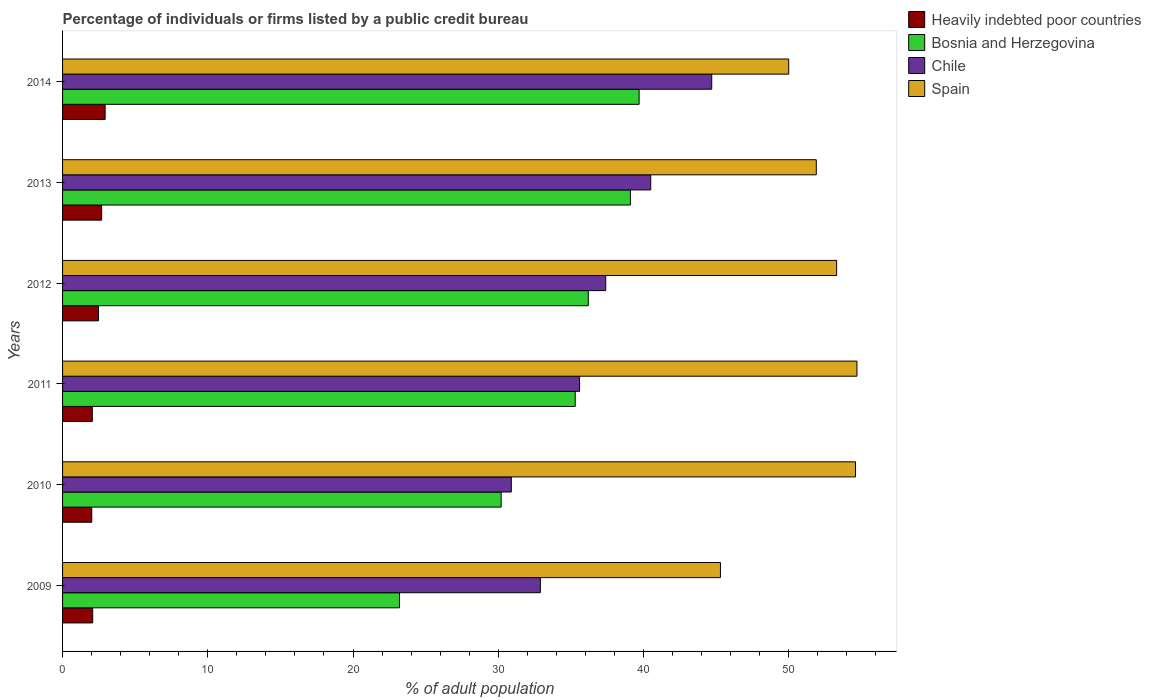How many different coloured bars are there?
Make the answer very short. 4. How many groups of bars are there?
Make the answer very short. 6. Are the number of bars per tick equal to the number of legend labels?
Ensure brevity in your answer.  Yes. How many bars are there on the 3rd tick from the bottom?
Offer a very short reply. 4. In how many cases, is the number of bars for a given year not equal to the number of legend labels?
Your answer should be very brief. 0. What is the percentage of population listed by a public credit bureau in Spain in 2011?
Your answer should be compact. 54.7. Across all years, what is the maximum percentage of population listed by a public credit bureau in Bosnia and Herzegovina?
Provide a short and direct response. 39.7. Across all years, what is the minimum percentage of population listed by a public credit bureau in Heavily indebted poor countries?
Your response must be concise. 2.01. In which year was the percentage of population listed by a public credit bureau in Heavily indebted poor countries minimum?
Offer a very short reply. 2010. What is the total percentage of population listed by a public credit bureau in Chile in the graph?
Offer a terse response. 222. What is the difference between the percentage of population listed by a public credit bureau in Heavily indebted poor countries in 2013 and that in 2014?
Offer a terse response. -0.24. What is the difference between the percentage of population listed by a public credit bureau in Spain in 2009 and the percentage of population listed by a public credit bureau in Chile in 2011?
Your answer should be compact. 9.7. In the year 2013, what is the difference between the percentage of population listed by a public credit bureau in Chile and percentage of population listed by a public credit bureau in Heavily indebted poor countries?
Offer a terse response. 37.81. In how many years, is the percentage of population listed by a public credit bureau in Bosnia and Herzegovina greater than 26 %?
Your response must be concise. 5. What is the ratio of the percentage of population listed by a public credit bureau in Bosnia and Herzegovina in 2011 to that in 2014?
Make the answer very short. 0.89. Is the difference between the percentage of population listed by a public credit bureau in Chile in 2010 and 2014 greater than the difference between the percentage of population listed by a public credit bureau in Heavily indebted poor countries in 2010 and 2014?
Give a very brief answer. No. What is the difference between the highest and the second highest percentage of population listed by a public credit bureau in Spain?
Give a very brief answer. 0.1. What is the difference between the highest and the lowest percentage of population listed by a public credit bureau in Heavily indebted poor countries?
Offer a very short reply. 0.92. What does the 1st bar from the bottom in 2013 represents?
Provide a succinct answer. Heavily indebted poor countries. How many bars are there?
Offer a very short reply. 24. How many years are there in the graph?
Ensure brevity in your answer.  6. What is the difference between two consecutive major ticks on the X-axis?
Offer a terse response. 10. Where does the legend appear in the graph?
Ensure brevity in your answer.  Top right. How are the legend labels stacked?
Give a very brief answer. Vertical. What is the title of the graph?
Offer a terse response. Percentage of individuals or firms listed by a public credit bureau. Does "Guam" appear as one of the legend labels in the graph?
Provide a short and direct response. No. What is the label or title of the X-axis?
Make the answer very short. % of adult population. What is the label or title of the Y-axis?
Make the answer very short. Years. What is the % of adult population of Heavily indebted poor countries in 2009?
Offer a terse response. 2.07. What is the % of adult population in Bosnia and Herzegovina in 2009?
Provide a short and direct response. 23.2. What is the % of adult population of Chile in 2009?
Give a very brief answer. 32.9. What is the % of adult population in Spain in 2009?
Provide a succinct answer. 45.3. What is the % of adult population of Heavily indebted poor countries in 2010?
Give a very brief answer. 2.01. What is the % of adult population of Bosnia and Herzegovina in 2010?
Provide a short and direct response. 30.2. What is the % of adult population in Chile in 2010?
Your response must be concise. 30.9. What is the % of adult population in Spain in 2010?
Provide a succinct answer. 54.6. What is the % of adult population in Heavily indebted poor countries in 2011?
Offer a terse response. 2.05. What is the % of adult population in Bosnia and Herzegovina in 2011?
Your answer should be compact. 35.3. What is the % of adult population in Chile in 2011?
Give a very brief answer. 35.6. What is the % of adult population of Spain in 2011?
Give a very brief answer. 54.7. What is the % of adult population of Heavily indebted poor countries in 2012?
Your answer should be very brief. 2.48. What is the % of adult population of Bosnia and Herzegovina in 2012?
Keep it short and to the point. 36.2. What is the % of adult population of Chile in 2012?
Make the answer very short. 37.4. What is the % of adult population of Spain in 2012?
Provide a succinct answer. 53.3. What is the % of adult population of Heavily indebted poor countries in 2013?
Offer a very short reply. 2.69. What is the % of adult population of Bosnia and Herzegovina in 2013?
Provide a short and direct response. 39.1. What is the % of adult population in Chile in 2013?
Give a very brief answer. 40.5. What is the % of adult population of Spain in 2013?
Your response must be concise. 51.9. What is the % of adult population of Heavily indebted poor countries in 2014?
Give a very brief answer. 2.93. What is the % of adult population in Bosnia and Herzegovina in 2014?
Provide a succinct answer. 39.7. What is the % of adult population in Chile in 2014?
Your answer should be compact. 44.7. Across all years, what is the maximum % of adult population of Heavily indebted poor countries?
Your response must be concise. 2.93. Across all years, what is the maximum % of adult population of Bosnia and Herzegovina?
Offer a terse response. 39.7. Across all years, what is the maximum % of adult population in Chile?
Your answer should be very brief. 44.7. Across all years, what is the maximum % of adult population of Spain?
Offer a terse response. 54.7. Across all years, what is the minimum % of adult population of Heavily indebted poor countries?
Keep it short and to the point. 2.01. Across all years, what is the minimum % of adult population in Bosnia and Herzegovina?
Give a very brief answer. 23.2. Across all years, what is the minimum % of adult population in Chile?
Offer a terse response. 30.9. Across all years, what is the minimum % of adult population of Spain?
Offer a very short reply. 45.3. What is the total % of adult population of Heavily indebted poor countries in the graph?
Make the answer very short. 14.23. What is the total % of adult population in Bosnia and Herzegovina in the graph?
Provide a succinct answer. 203.7. What is the total % of adult population of Chile in the graph?
Your response must be concise. 222. What is the total % of adult population in Spain in the graph?
Make the answer very short. 309.8. What is the difference between the % of adult population in Heavily indebted poor countries in 2009 and that in 2010?
Your answer should be compact. 0.06. What is the difference between the % of adult population of Bosnia and Herzegovina in 2009 and that in 2010?
Provide a succinct answer. -7. What is the difference between the % of adult population of Spain in 2009 and that in 2010?
Your answer should be compact. -9.3. What is the difference between the % of adult population in Heavily indebted poor countries in 2009 and that in 2011?
Offer a very short reply. 0.03. What is the difference between the % of adult population in Bosnia and Herzegovina in 2009 and that in 2011?
Offer a very short reply. -12.1. What is the difference between the % of adult population of Chile in 2009 and that in 2011?
Offer a terse response. -2.7. What is the difference between the % of adult population in Heavily indebted poor countries in 2009 and that in 2012?
Offer a very short reply. -0.4. What is the difference between the % of adult population in Chile in 2009 and that in 2012?
Ensure brevity in your answer.  -4.5. What is the difference between the % of adult population of Heavily indebted poor countries in 2009 and that in 2013?
Your answer should be compact. -0.62. What is the difference between the % of adult population of Bosnia and Herzegovina in 2009 and that in 2013?
Provide a succinct answer. -15.9. What is the difference between the % of adult population in Chile in 2009 and that in 2013?
Give a very brief answer. -7.6. What is the difference between the % of adult population of Spain in 2009 and that in 2013?
Provide a succinct answer. -6.6. What is the difference between the % of adult population of Heavily indebted poor countries in 2009 and that in 2014?
Offer a terse response. -0.86. What is the difference between the % of adult population of Bosnia and Herzegovina in 2009 and that in 2014?
Your answer should be very brief. -16.5. What is the difference between the % of adult population of Spain in 2009 and that in 2014?
Your answer should be very brief. -4.7. What is the difference between the % of adult population in Heavily indebted poor countries in 2010 and that in 2011?
Your response must be concise. -0.04. What is the difference between the % of adult population in Bosnia and Herzegovina in 2010 and that in 2011?
Make the answer very short. -5.1. What is the difference between the % of adult population in Spain in 2010 and that in 2011?
Your response must be concise. -0.1. What is the difference between the % of adult population of Heavily indebted poor countries in 2010 and that in 2012?
Your response must be concise. -0.47. What is the difference between the % of adult population of Chile in 2010 and that in 2012?
Ensure brevity in your answer.  -6.5. What is the difference between the % of adult population in Heavily indebted poor countries in 2010 and that in 2013?
Ensure brevity in your answer.  -0.68. What is the difference between the % of adult population of Heavily indebted poor countries in 2010 and that in 2014?
Ensure brevity in your answer.  -0.92. What is the difference between the % of adult population of Spain in 2010 and that in 2014?
Provide a succinct answer. 4.6. What is the difference between the % of adult population of Heavily indebted poor countries in 2011 and that in 2012?
Provide a short and direct response. -0.43. What is the difference between the % of adult population in Bosnia and Herzegovina in 2011 and that in 2012?
Your answer should be compact. -0.9. What is the difference between the % of adult population in Chile in 2011 and that in 2012?
Offer a very short reply. -1.8. What is the difference between the % of adult population of Spain in 2011 and that in 2012?
Your response must be concise. 1.4. What is the difference between the % of adult population in Heavily indebted poor countries in 2011 and that in 2013?
Make the answer very short. -0.64. What is the difference between the % of adult population in Bosnia and Herzegovina in 2011 and that in 2013?
Offer a very short reply. -3.8. What is the difference between the % of adult population in Chile in 2011 and that in 2013?
Ensure brevity in your answer.  -4.9. What is the difference between the % of adult population in Spain in 2011 and that in 2013?
Keep it short and to the point. 2.8. What is the difference between the % of adult population of Heavily indebted poor countries in 2011 and that in 2014?
Provide a short and direct response. -0.88. What is the difference between the % of adult population in Bosnia and Herzegovina in 2011 and that in 2014?
Provide a short and direct response. -4.4. What is the difference between the % of adult population in Heavily indebted poor countries in 2012 and that in 2013?
Provide a short and direct response. -0.22. What is the difference between the % of adult population in Bosnia and Herzegovina in 2012 and that in 2013?
Offer a terse response. -2.9. What is the difference between the % of adult population of Chile in 2012 and that in 2013?
Give a very brief answer. -3.1. What is the difference between the % of adult population of Spain in 2012 and that in 2013?
Your answer should be compact. 1.4. What is the difference between the % of adult population in Heavily indebted poor countries in 2012 and that in 2014?
Offer a very short reply. -0.46. What is the difference between the % of adult population of Chile in 2012 and that in 2014?
Keep it short and to the point. -7.3. What is the difference between the % of adult population of Heavily indebted poor countries in 2013 and that in 2014?
Give a very brief answer. -0.24. What is the difference between the % of adult population of Spain in 2013 and that in 2014?
Offer a very short reply. 1.9. What is the difference between the % of adult population in Heavily indebted poor countries in 2009 and the % of adult population in Bosnia and Herzegovina in 2010?
Provide a succinct answer. -28.13. What is the difference between the % of adult population of Heavily indebted poor countries in 2009 and the % of adult population of Chile in 2010?
Your answer should be very brief. -28.83. What is the difference between the % of adult population of Heavily indebted poor countries in 2009 and the % of adult population of Spain in 2010?
Ensure brevity in your answer.  -52.53. What is the difference between the % of adult population in Bosnia and Herzegovina in 2009 and the % of adult population in Chile in 2010?
Your response must be concise. -7.7. What is the difference between the % of adult population in Bosnia and Herzegovina in 2009 and the % of adult population in Spain in 2010?
Provide a succinct answer. -31.4. What is the difference between the % of adult population of Chile in 2009 and the % of adult population of Spain in 2010?
Make the answer very short. -21.7. What is the difference between the % of adult population in Heavily indebted poor countries in 2009 and the % of adult population in Bosnia and Herzegovina in 2011?
Give a very brief answer. -33.23. What is the difference between the % of adult population in Heavily indebted poor countries in 2009 and the % of adult population in Chile in 2011?
Keep it short and to the point. -33.53. What is the difference between the % of adult population in Heavily indebted poor countries in 2009 and the % of adult population in Spain in 2011?
Ensure brevity in your answer.  -52.63. What is the difference between the % of adult population of Bosnia and Herzegovina in 2009 and the % of adult population of Chile in 2011?
Offer a terse response. -12.4. What is the difference between the % of adult population in Bosnia and Herzegovina in 2009 and the % of adult population in Spain in 2011?
Your response must be concise. -31.5. What is the difference between the % of adult population in Chile in 2009 and the % of adult population in Spain in 2011?
Your answer should be compact. -21.8. What is the difference between the % of adult population of Heavily indebted poor countries in 2009 and the % of adult population of Bosnia and Herzegovina in 2012?
Offer a very short reply. -34.13. What is the difference between the % of adult population of Heavily indebted poor countries in 2009 and the % of adult population of Chile in 2012?
Offer a terse response. -35.33. What is the difference between the % of adult population in Heavily indebted poor countries in 2009 and the % of adult population in Spain in 2012?
Your answer should be very brief. -51.23. What is the difference between the % of adult population of Bosnia and Herzegovina in 2009 and the % of adult population of Chile in 2012?
Provide a short and direct response. -14.2. What is the difference between the % of adult population in Bosnia and Herzegovina in 2009 and the % of adult population in Spain in 2012?
Keep it short and to the point. -30.1. What is the difference between the % of adult population of Chile in 2009 and the % of adult population of Spain in 2012?
Make the answer very short. -20.4. What is the difference between the % of adult population of Heavily indebted poor countries in 2009 and the % of adult population of Bosnia and Herzegovina in 2013?
Your answer should be very brief. -37.03. What is the difference between the % of adult population in Heavily indebted poor countries in 2009 and the % of adult population in Chile in 2013?
Provide a short and direct response. -38.43. What is the difference between the % of adult population in Heavily indebted poor countries in 2009 and the % of adult population in Spain in 2013?
Your answer should be very brief. -49.83. What is the difference between the % of adult population of Bosnia and Herzegovina in 2009 and the % of adult population of Chile in 2013?
Offer a terse response. -17.3. What is the difference between the % of adult population of Bosnia and Herzegovina in 2009 and the % of adult population of Spain in 2013?
Keep it short and to the point. -28.7. What is the difference between the % of adult population of Heavily indebted poor countries in 2009 and the % of adult population of Bosnia and Herzegovina in 2014?
Keep it short and to the point. -37.63. What is the difference between the % of adult population of Heavily indebted poor countries in 2009 and the % of adult population of Chile in 2014?
Give a very brief answer. -42.63. What is the difference between the % of adult population of Heavily indebted poor countries in 2009 and the % of adult population of Spain in 2014?
Offer a terse response. -47.93. What is the difference between the % of adult population in Bosnia and Herzegovina in 2009 and the % of adult population in Chile in 2014?
Your answer should be compact. -21.5. What is the difference between the % of adult population of Bosnia and Herzegovina in 2009 and the % of adult population of Spain in 2014?
Offer a very short reply. -26.8. What is the difference between the % of adult population in Chile in 2009 and the % of adult population in Spain in 2014?
Your answer should be compact. -17.1. What is the difference between the % of adult population in Heavily indebted poor countries in 2010 and the % of adult population in Bosnia and Herzegovina in 2011?
Offer a very short reply. -33.29. What is the difference between the % of adult population in Heavily indebted poor countries in 2010 and the % of adult population in Chile in 2011?
Provide a succinct answer. -33.59. What is the difference between the % of adult population of Heavily indebted poor countries in 2010 and the % of adult population of Spain in 2011?
Keep it short and to the point. -52.69. What is the difference between the % of adult population of Bosnia and Herzegovina in 2010 and the % of adult population of Chile in 2011?
Offer a terse response. -5.4. What is the difference between the % of adult population of Bosnia and Herzegovina in 2010 and the % of adult population of Spain in 2011?
Provide a succinct answer. -24.5. What is the difference between the % of adult population in Chile in 2010 and the % of adult population in Spain in 2011?
Ensure brevity in your answer.  -23.8. What is the difference between the % of adult population of Heavily indebted poor countries in 2010 and the % of adult population of Bosnia and Herzegovina in 2012?
Make the answer very short. -34.19. What is the difference between the % of adult population of Heavily indebted poor countries in 2010 and the % of adult population of Chile in 2012?
Offer a very short reply. -35.39. What is the difference between the % of adult population of Heavily indebted poor countries in 2010 and the % of adult population of Spain in 2012?
Offer a very short reply. -51.29. What is the difference between the % of adult population of Bosnia and Herzegovina in 2010 and the % of adult population of Chile in 2012?
Offer a terse response. -7.2. What is the difference between the % of adult population in Bosnia and Herzegovina in 2010 and the % of adult population in Spain in 2012?
Your answer should be very brief. -23.1. What is the difference between the % of adult population of Chile in 2010 and the % of adult population of Spain in 2012?
Ensure brevity in your answer.  -22.4. What is the difference between the % of adult population in Heavily indebted poor countries in 2010 and the % of adult population in Bosnia and Herzegovina in 2013?
Your answer should be compact. -37.09. What is the difference between the % of adult population in Heavily indebted poor countries in 2010 and the % of adult population in Chile in 2013?
Give a very brief answer. -38.49. What is the difference between the % of adult population of Heavily indebted poor countries in 2010 and the % of adult population of Spain in 2013?
Ensure brevity in your answer.  -49.89. What is the difference between the % of adult population of Bosnia and Herzegovina in 2010 and the % of adult population of Chile in 2013?
Keep it short and to the point. -10.3. What is the difference between the % of adult population in Bosnia and Herzegovina in 2010 and the % of adult population in Spain in 2013?
Your answer should be very brief. -21.7. What is the difference between the % of adult population in Heavily indebted poor countries in 2010 and the % of adult population in Bosnia and Herzegovina in 2014?
Keep it short and to the point. -37.69. What is the difference between the % of adult population in Heavily indebted poor countries in 2010 and the % of adult population in Chile in 2014?
Your answer should be very brief. -42.69. What is the difference between the % of adult population of Heavily indebted poor countries in 2010 and the % of adult population of Spain in 2014?
Your response must be concise. -47.99. What is the difference between the % of adult population in Bosnia and Herzegovina in 2010 and the % of adult population in Spain in 2014?
Provide a short and direct response. -19.8. What is the difference between the % of adult population in Chile in 2010 and the % of adult population in Spain in 2014?
Offer a terse response. -19.1. What is the difference between the % of adult population of Heavily indebted poor countries in 2011 and the % of adult population of Bosnia and Herzegovina in 2012?
Provide a short and direct response. -34.15. What is the difference between the % of adult population of Heavily indebted poor countries in 2011 and the % of adult population of Chile in 2012?
Provide a short and direct response. -35.35. What is the difference between the % of adult population in Heavily indebted poor countries in 2011 and the % of adult population in Spain in 2012?
Your answer should be very brief. -51.25. What is the difference between the % of adult population in Bosnia and Herzegovina in 2011 and the % of adult population in Chile in 2012?
Your answer should be compact. -2.1. What is the difference between the % of adult population of Chile in 2011 and the % of adult population of Spain in 2012?
Your response must be concise. -17.7. What is the difference between the % of adult population in Heavily indebted poor countries in 2011 and the % of adult population in Bosnia and Herzegovina in 2013?
Keep it short and to the point. -37.05. What is the difference between the % of adult population in Heavily indebted poor countries in 2011 and the % of adult population in Chile in 2013?
Your answer should be compact. -38.45. What is the difference between the % of adult population in Heavily indebted poor countries in 2011 and the % of adult population in Spain in 2013?
Your response must be concise. -49.85. What is the difference between the % of adult population in Bosnia and Herzegovina in 2011 and the % of adult population in Chile in 2013?
Offer a very short reply. -5.2. What is the difference between the % of adult population of Bosnia and Herzegovina in 2011 and the % of adult population of Spain in 2013?
Ensure brevity in your answer.  -16.6. What is the difference between the % of adult population of Chile in 2011 and the % of adult population of Spain in 2013?
Provide a short and direct response. -16.3. What is the difference between the % of adult population of Heavily indebted poor countries in 2011 and the % of adult population of Bosnia and Herzegovina in 2014?
Your answer should be compact. -37.65. What is the difference between the % of adult population of Heavily indebted poor countries in 2011 and the % of adult population of Chile in 2014?
Ensure brevity in your answer.  -42.65. What is the difference between the % of adult population in Heavily indebted poor countries in 2011 and the % of adult population in Spain in 2014?
Offer a terse response. -47.95. What is the difference between the % of adult population of Bosnia and Herzegovina in 2011 and the % of adult population of Chile in 2014?
Your answer should be compact. -9.4. What is the difference between the % of adult population in Bosnia and Herzegovina in 2011 and the % of adult population in Spain in 2014?
Keep it short and to the point. -14.7. What is the difference between the % of adult population in Chile in 2011 and the % of adult population in Spain in 2014?
Your answer should be compact. -14.4. What is the difference between the % of adult population of Heavily indebted poor countries in 2012 and the % of adult population of Bosnia and Herzegovina in 2013?
Your answer should be very brief. -36.62. What is the difference between the % of adult population in Heavily indebted poor countries in 2012 and the % of adult population in Chile in 2013?
Your answer should be compact. -38.02. What is the difference between the % of adult population of Heavily indebted poor countries in 2012 and the % of adult population of Spain in 2013?
Make the answer very short. -49.42. What is the difference between the % of adult population in Bosnia and Herzegovina in 2012 and the % of adult population in Chile in 2013?
Your response must be concise. -4.3. What is the difference between the % of adult population in Bosnia and Herzegovina in 2012 and the % of adult population in Spain in 2013?
Offer a very short reply. -15.7. What is the difference between the % of adult population of Heavily indebted poor countries in 2012 and the % of adult population of Bosnia and Herzegovina in 2014?
Your answer should be compact. -37.22. What is the difference between the % of adult population of Heavily indebted poor countries in 2012 and the % of adult population of Chile in 2014?
Ensure brevity in your answer.  -42.22. What is the difference between the % of adult population of Heavily indebted poor countries in 2012 and the % of adult population of Spain in 2014?
Offer a very short reply. -47.52. What is the difference between the % of adult population in Chile in 2012 and the % of adult population in Spain in 2014?
Your answer should be very brief. -12.6. What is the difference between the % of adult population in Heavily indebted poor countries in 2013 and the % of adult population in Bosnia and Herzegovina in 2014?
Your answer should be compact. -37.01. What is the difference between the % of adult population of Heavily indebted poor countries in 2013 and the % of adult population of Chile in 2014?
Offer a very short reply. -42.01. What is the difference between the % of adult population of Heavily indebted poor countries in 2013 and the % of adult population of Spain in 2014?
Your response must be concise. -47.31. What is the difference between the % of adult population in Bosnia and Herzegovina in 2013 and the % of adult population in Chile in 2014?
Offer a very short reply. -5.6. What is the difference between the % of adult population of Bosnia and Herzegovina in 2013 and the % of adult population of Spain in 2014?
Your response must be concise. -10.9. What is the average % of adult population of Heavily indebted poor countries per year?
Provide a short and direct response. 2.37. What is the average % of adult population in Bosnia and Herzegovina per year?
Provide a succinct answer. 33.95. What is the average % of adult population in Spain per year?
Your answer should be very brief. 51.63. In the year 2009, what is the difference between the % of adult population in Heavily indebted poor countries and % of adult population in Bosnia and Herzegovina?
Give a very brief answer. -21.13. In the year 2009, what is the difference between the % of adult population of Heavily indebted poor countries and % of adult population of Chile?
Keep it short and to the point. -30.83. In the year 2009, what is the difference between the % of adult population in Heavily indebted poor countries and % of adult population in Spain?
Provide a short and direct response. -43.23. In the year 2009, what is the difference between the % of adult population in Bosnia and Herzegovina and % of adult population in Chile?
Your answer should be very brief. -9.7. In the year 2009, what is the difference between the % of adult population of Bosnia and Herzegovina and % of adult population of Spain?
Ensure brevity in your answer.  -22.1. In the year 2009, what is the difference between the % of adult population of Chile and % of adult population of Spain?
Your response must be concise. -12.4. In the year 2010, what is the difference between the % of adult population in Heavily indebted poor countries and % of adult population in Bosnia and Herzegovina?
Your response must be concise. -28.19. In the year 2010, what is the difference between the % of adult population of Heavily indebted poor countries and % of adult population of Chile?
Provide a succinct answer. -28.89. In the year 2010, what is the difference between the % of adult population of Heavily indebted poor countries and % of adult population of Spain?
Keep it short and to the point. -52.59. In the year 2010, what is the difference between the % of adult population in Bosnia and Herzegovina and % of adult population in Chile?
Make the answer very short. -0.7. In the year 2010, what is the difference between the % of adult population of Bosnia and Herzegovina and % of adult population of Spain?
Your response must be concise. -24.4. In the year 2010, what is the difference between the % of adult population in Chile and % of adult population in Spain?
Provide a succinct answer. -23.7. In the year 2011, what is the difference between the % of adult population in Heavily indebted poor countries and % of adult population in Bosnia and Herzegovina?
Ensure brevity in your answer.  -33.25. In the year 2011, what is the difference between the % of adult population of Heavily indebted poor countries and % of adult population of Chile?
Offer a terse response. -33.55. In the year 2011, what is the difference between the % of adult population in Heavily indebted poor countries and % of adult population in Spain?
Give a very brief answer. -52.65. In the year 2011, what is the difference between the % of adult population in Bosnia and Herzegovina and % of adult population in Spain?
Your response must be concise. -19.4. In the year 2011, what is the difference between the % of adult population of Chile and % of adult population of Spain?
Keep it short and to the point. -19.1. In the year 2012, what is the difference between the % of adult population in Heavily indebted poor countries and % of adult population in Bosnia and Herzegovina?
Your answer should be very brief. -33.72. In the year 2012, what is the difference between the % of adult population of Heavily indebted poor countries and % of adult population of Chile?
Your answer should be compact. -34.92. In the year 2012, what is the difference between the % of adult population of Heavily indebted poor countries and % of adult population of Spain?
Keep it short and to the point. -50.82. In the year 2012, what is the difference between the % of adult population in Bosnia and Herzegovina and % of adult population in Spain?
Your response must be concise. -17.1. In the year 2012, what is the difference between the % of adult population in Chile and % of adult population in Spain?
Your response must be concise. -15.9. In the year 2013, what is the difference between the % of adult population of Heavily indebted poor countries and % of adult population of Bosnia and Herzegovina?
Your answer should be very brief. -36.41. In the year 2013, what is the difference between the % of adult population in Heavily indebted poor countries and % of adult population in Chile?
Provide a short and direct response. -37.81. In the year 2013, what is the difference between the % of adult population in Heavily indebted poor countries and % of adult population in Spain?
Your response must be concise. -49.21. In the year 2013, what is the difference between the % of adult population in Bosnia and Herzegovina and % of adult population in Spain?
Keep it short and to the point. -12.8. In the year 2013, what is the difference between the % of adult population in Chile and % of adult population in Spain?
Give a very brief answer. -11.4. In the year 2014, what is the difference between the % of adult population of Heavily indebted poor countries and % of adult population of Bosnia and Herzegovina?
Provide a succinct answer. -36.77. In the year 2014, what is the difference between the % of adult population in Heavily indebted poor countries and % of adult population in Chile?
Offer a very short reply. -41.77. In the year 2014, what is the difference between the % of adult population of Heavily indebted poor countries and % of adult population of Spain?
Provide a short and direct response. -47.07. In the year 2014, what is the difference between the % of adult population in Bosnia and Herzegovina and % of adult population in Chile?
Your answer should be compact. -5. In the year 2014, what is the difference between the % of adult population of Bosnia and Herzegovina and % of adult population of Spain?
Your answer should be compact. -10.3. What is the ratio of the % of adult population of Heavily indebted poor countries in 2009 to that in 2010?
Provide a short and direct response. 1.03. What is the ratio of the % of adult population in Bosnia and Herzegovina in 2009 to that in 2010?
Offer a very short reply. 0.77. What is the ratio of the % of adult population of Chile in 2009 to that in 2010?
Ensure brevity in your answer.  1.06. What is the ratio of the % of adult population of Spain in 2009 to that in 2010?
Provide a short and direct response. 0.83. What is the ratio of the % of adult population in Heavily indebted poor countries in 2009 to that in 2011?
Provide a succinct answer. 1.01. What is the ratio of the % of adult population in Bosnia and Herzegovina in 2009 to that in 2011?
Offer a terse response. 0.66. What is the ratio of the % of adult population of Chile in 2009 to that in 2011?
Keep it short and to the point. 0.92. What is the ratio of the % of adult population in Spain in 2009 to that in 2011?
Give a very brief answer. 0.83. What is the ratio of the % of adult population of Heavily indebted poor countries in 2009 to that in 2012?
Keep it short and to the point. 0.84. What is the ratio of the % of adult population in Bosnia and Herzegovina in 2009 to that in 2012?
Your answer should be very brief. 0.64. What is the ratio of the % of adult population of Chile in 2009 to that in 2012?
Provide a short and direct response. 0.88. What is the ratio of the % of adult population in Spain in 2009 to that in 2012?
Provide a succinct answer. 0.85. What is the ratio of the % of adult population in Heavily indebted poor countries in 2009 to that in 2013?
Make the answer very short. 0.77. What is the ratio of the % of adult population in Bosnia and Herzegovina in 2009 to that in 2013?
Provide a short and direct response. 0.59. What is the ratio of the % of adult population of Chile in 2009 to that in 2013?
Offer a terse response. 0.81. What is the ratio of the % of adult population of Spain in 2009 to that in 2013?
Ensure brevity in your answer.  0.87. What is the ratio of the % of adult population in Heavily indebted poor countries in 2009 to that in 2014?
Offer a terse response. 0.71. What is the ratio of the % of adult population in Bosnia and Herzegovina in 2009 to that in 2014?
Make the answer very short. 0.58. What is the ratio of the % of adult population in Chile in 2009 to that in 2014?
Make the answer very short. 0.74. What is the ratio of the % of adult population of Spain in 2009 to that in 2014?
Give a very brief answer. 0.91. What is the ratio of the % of adult population of Bosnia and Herzegovina in 2010 to that in 2011?
Provide a short and direct response. 0.86. What is the ratio of the % of adult population in Chile in 2010 to that in 2011?
Your response must be concise. 0.87. What is the ratio of the % of adult population of Heavily indebted poor countries in 2010 to that in 2012?
Provide a succinct answer. 0.81. What is the ratio of the % of adult population in Bosnia and Herzegovina in 2010 to that in 2012?
Offer a terse response. 0.83. What is the ratio of the % of adult population of Chile in 2010 to that in 2012?
Provide a succinct answer. 0.83. What is the ratio of the % of adult population of Spain in 2010 to that in 2012?
Your answer should be very brief. 1.02. What is the ratio of the % of adult population of Heavily indebted poor countries in 2010 to that in 2013?
Offer a terse response. 0.75. What is the ratio of the % of adult population of Bosnia and Herzegovina in 2010 to that in 2013?
Your answer should be compact. 0.77. What is the ratio of the % of adult population of Chile in 2010 to that in 2013?
Your response must be concise. 0.76. What is the ratio of the % of adult population of Spain in 2010 to that in 2013?
Provide a succinct answer. 1.05. What is the ratio of the % of adult population in Heavily indebted poor countries in 2010 to that in 2014?
Your answer should be compact. 0.69. What is the ratio of the % of adult population of Bosnia and Herzegovina in 2010 to that in 2014?
Offer a terse response. 0.76. What is the ratio of the % of adult population in Chile in 2010 to that in 2014?
Give a very brief answer. 0.69. What is the ratio of the % of adult population in Spain in 2010 to that in 2014?
Give a very brief answer. 1.09. What is the ratio of the % of adult population in Heavily indebted poor countries in 2011 to that in 2012?
Make the answer very short. 0.83. What is the ratio of the % of adult population in Bosnia and Herzegovina in 2011 to that in 2012?
Offer a very short reply. 0.98. What is the ratio of the % of adult population of Chile in 2011 to that in 2012?
Give a very brief answer. 0.95. What is the ratio of the % of adult population in Spain in 2011 to that in 2012?
Your response must be concise. 1.03. What is the ratio of the % of adult population of Heavily indebted poor countries in 2011 to that in 2013?
Your answer should be very brief. 0.76. What is the ratio of the % of adult population in Bosnia and Herzegovina in 2011 to that in 2013?
Offer a terse response. 0.9. What is the ratio of the % of adult population of Chile in 2011 to that in 2013?
Your answer should be compact. 0.88. What is the ratio of the % of adult population in Spain in 2011 to that in 2013?
Offer a very short reply. 1.05. What is the ratio of the % of adult population in Heavily indebted poor countries in 2011 to that in 2014?
Make the answer very short. 0.7. What is the ratio of the % of adult population in Bosnia and Herzegovina in 2011 to that in 2014?
Provide a short and direct response. 0.89. What is the ratio of the % of adult population of Chile in 2011 to that in 2014?
Offer a very short reply. 0.8. What is the ratio of the % of adult population of Spain in 2011 to that in 2014?
Offer a very short reply. 1.09. What is the ratio of the % of adult population in Heavily indebted poor countries in 2012 to that in 2013?
Your answer should be very brief. 0.92. What is the ratio of the % of adult population in Bosnia and Herzegovina in 2012 to that in 2013?
Your response must be concise. 0.93. What is the ratio of the % of adult population in Chile in 2012 to that in 2013?
Provide a succinct answer. 0.92. What is the ratio of the % of adult population of Heavily indebted poor countries in 2012 to that in 2014?
Ensure brevity in your answer.  0.84. What is the ratio of the % of adult population of Bosnia and Herzegovina in 2012 to that in 2014?
Provide a succinct answer. 0.91. What is the ratio of the % of adult population in Chile in 2012 to that in 2014?
Give a very brief answer. 0.84. What is the ratio of the % of adult population in Spain in 2012 to that in 2014?
Your answer should be compact. 1.07. What is the ratio of the % of adult population in Heavily indebted poor countries in 2013 to that in 2014?
Offer a terse response. 0.92. What is the ratio of the % of adult population of Bosnia and Herzegovina in 2013 to that in 2014?
Offer a terse response. 0.98. What is the ratio of the % of adult population of Chile in 2013 to that in 2014?
Your answer should be compact. 0.91. What is the ratio of the % of adult population of Spain in 2013 to that in 2014?
Your response must be concise. 1.04. What is the difference between the highest and the second highest % of adult population of Heavily indebted poor countries?
Ensure brevity in your answer.  0.24. What is the difference between the highest and the second highest % of adult population of Bosnia and Herzegovina?
Ensure brevity in your answer.  0.6. What is the difference between the highest and the lowest % of adult population in Heavily indebted poor countries?
Ensure brevity in your answer.  0.92. 